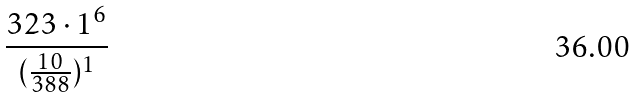<formula> <loc_0><loc_0><loc_500><loc_500>\frac { 3 2 3 \cdot 1 ^ { 6 } } { ( \frac { 1 0 } { 3 8 8 } ) ^ { 1 } }</formula> 